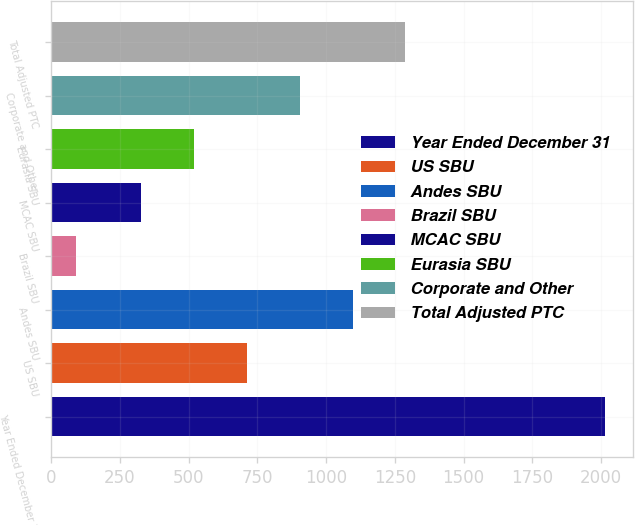<chart> <loc_0><loc_0><loc_500><loc_500><bar_chart><fcel>Year Ended December 31<fcel>US SBU<fcel>Andes SBU<fcel>Brazil SBU<fcel>MCAC SBU<fcel>Eurasia SBU<fcel>Corporate and Other<fcel>Total Adjusted PTC<nl><fcel>2015<fcel>711.6<fcel>1096.2<fcel>92<fcel>327<fcel>519.3<fcel>903.9<fcel>1288.5<nl></chart> 